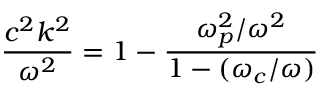<formula> <loc_0><loc_0><loc_500><loc_500>{ \frac { c ^ { 2 } k ^ { 2 } } { \omega ^ { 2 } } } = 1 - { \frac { \omega _ { p } ^ { 2 } / \omega ^ { 2 } } { 1 - ( \omega _ { c } / \omega ) } }</formula> 